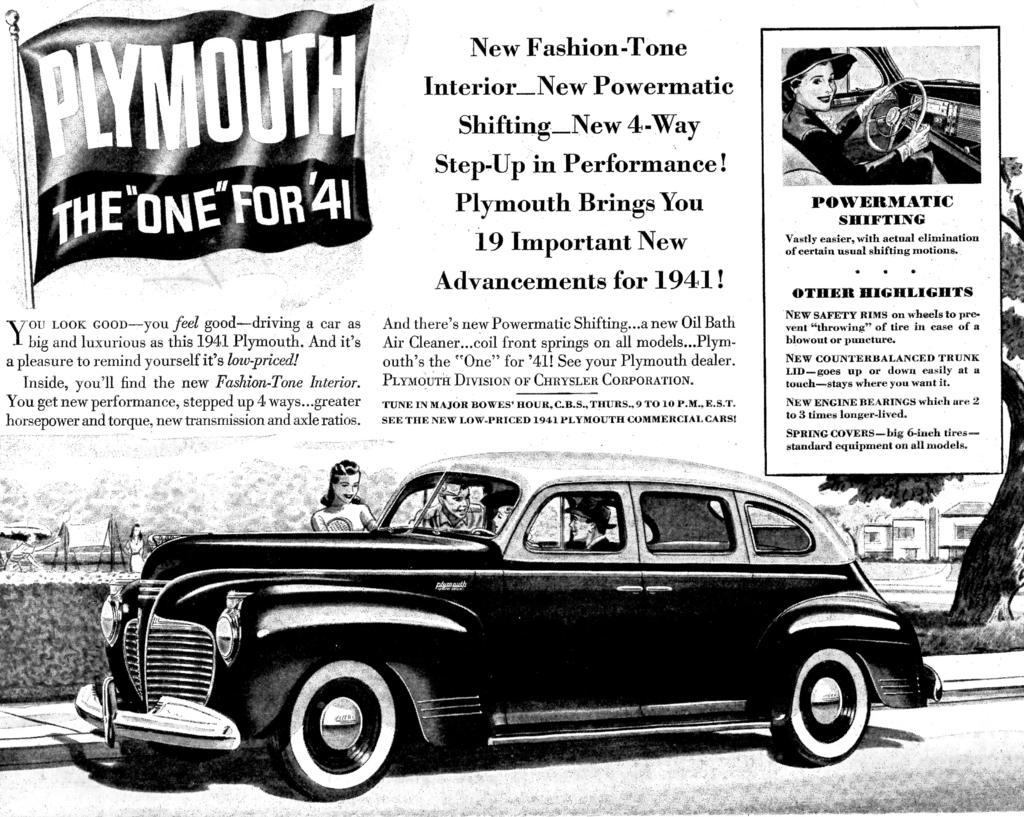Please provide a concise description of this image. There is a car where two people are sitting in it and another two are standing beside it and there is some thing written above it and there is a flag which has something written on it in the left top corner. 